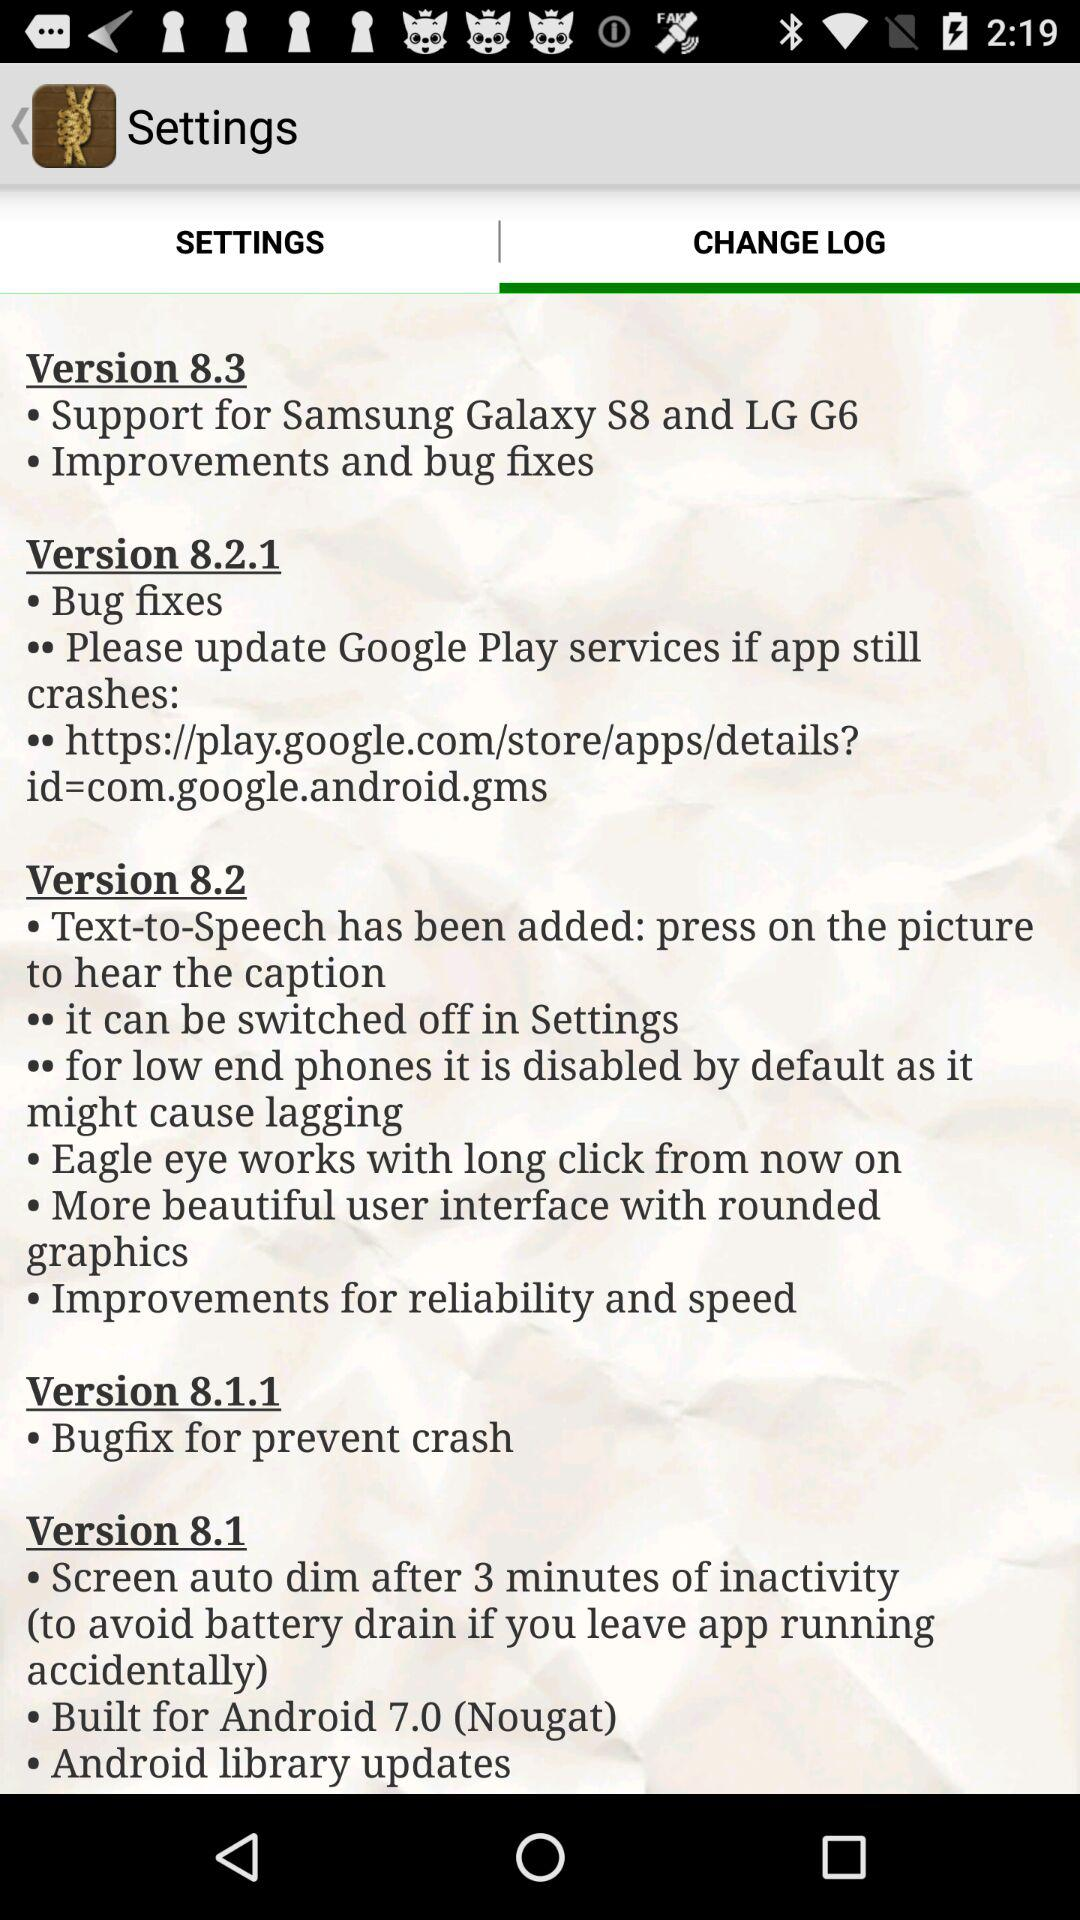What are the features of version 8.1.1? The feature of version 8.1.1 is "Bugfix for prevent crash". 